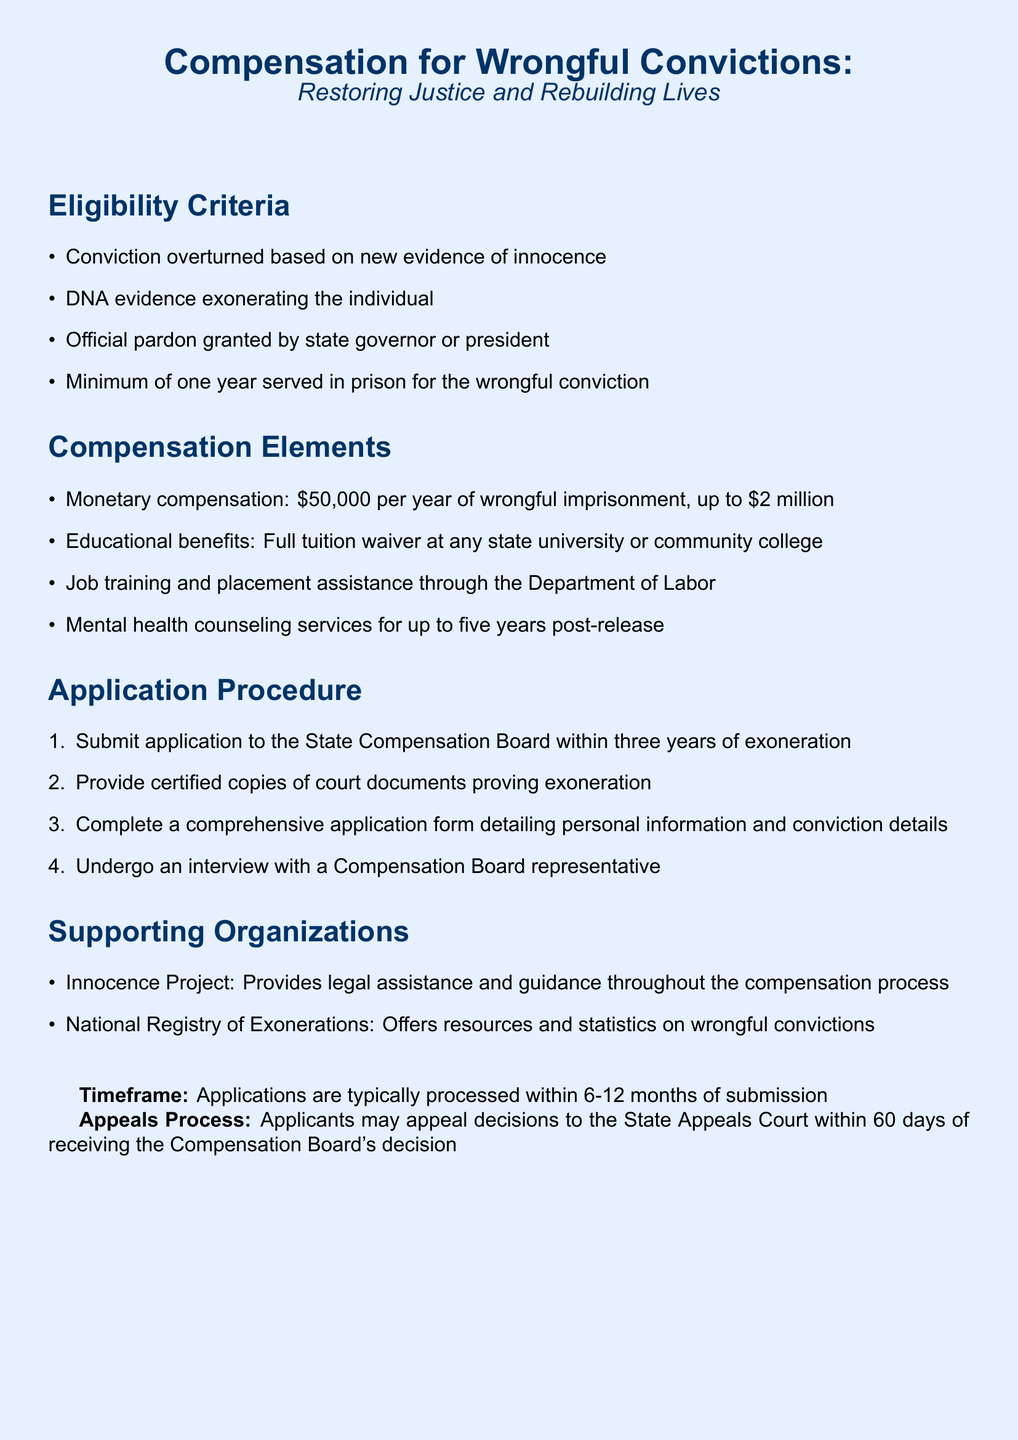What is the minimum prison time required for eligibility? The eligibility criteria states that a minimum of one year served in prison is required for the wrongful conviction.
Answer: one year What is the monetary compensation per year of wrongful imprisonment? The document specifies that individuals receive $50,000 per year of wrongful imprisonment.
Answer: $50,000 Who provides legal assistance during the compensation process? The supporting organization listed that provides legal assistance is the Innocence Project.
Answer: Innocence Project What is the maximum total compensation amount? According to the document, the maximum total compensation is up to $2 million.
Answer: $2 million How long do applicants typically have to apply after exoneration? The application must be submitted to the State Compensation Board within three years of exoneration.
Answer: three years What type of interview must applicants undergo? The document states that applicants must undergo an interview with a Compensation Board representative.
Answer: interview What is one of the educational benefits provided? The educational benefit mentioned includes a full tuition waiver at any state university or community college.
Answer: full tuition waiver What is the timeframe for application processing? The document notes that applications are typically processed within 6-12 months of submission.
Answer: 6-12 months 